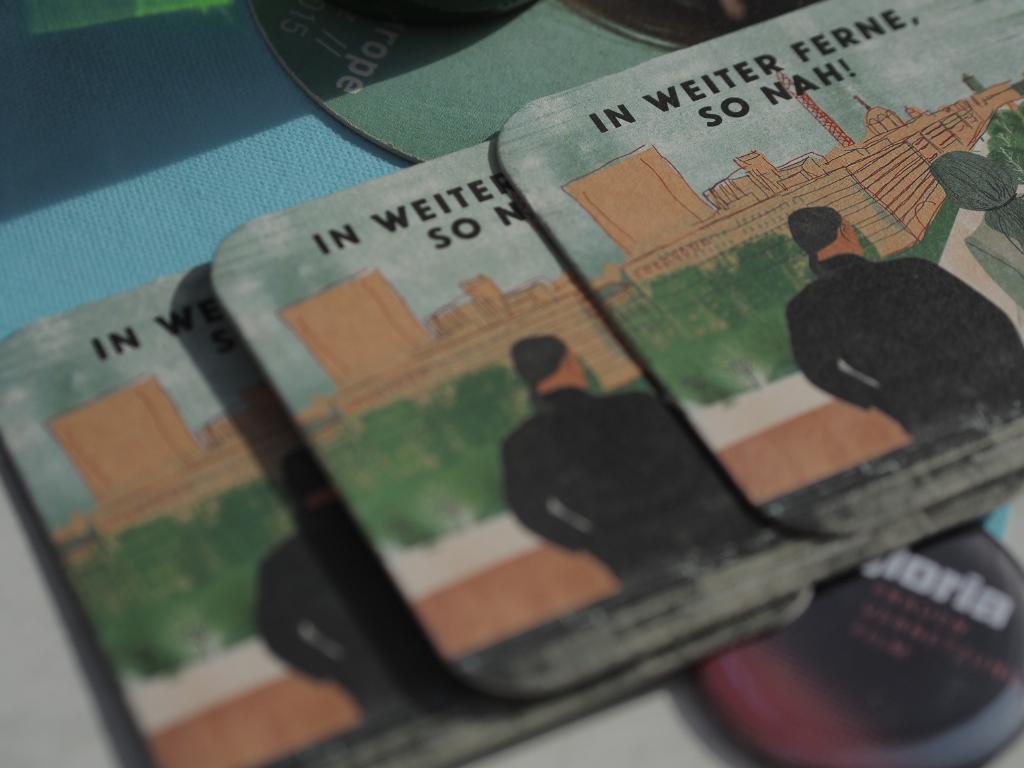Can you describe this image briefly? In this image i can see few objects and some text written on it. 